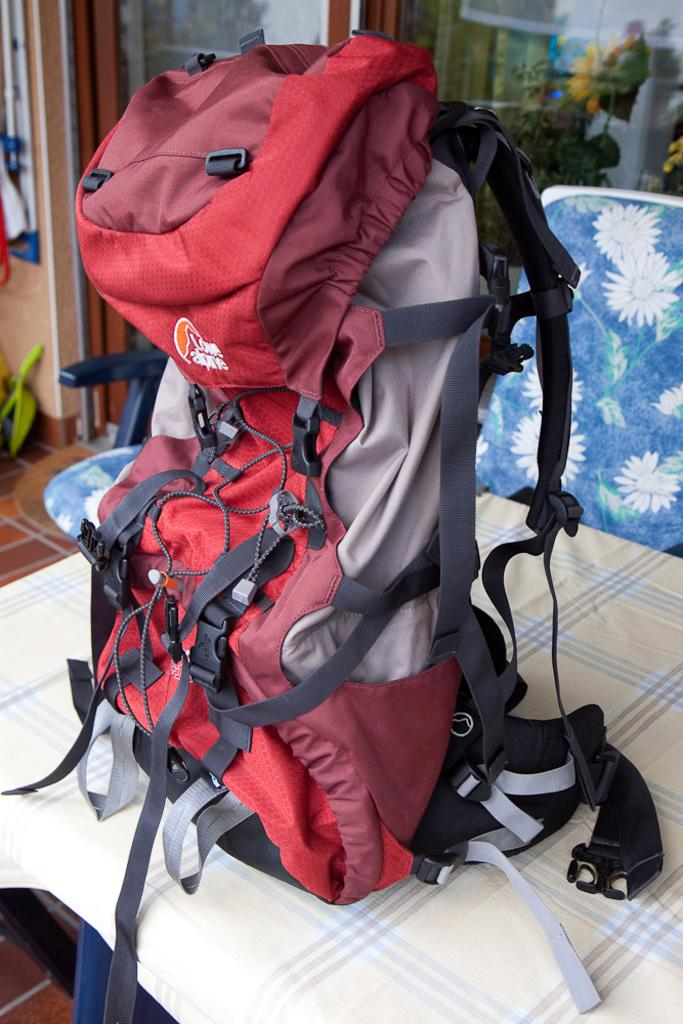What is placed on the table in the image? There is a backpack on the table. What type of furniture is present in the image? There is a chair in the image. What is covering the table in the image? There is a cloth on the table. What part of the room can be seen in the image? The floor is visible in the image. What direction is the test being taken in the image? There is no test present in the image, so it is not possible to determine the direction in which it would be taken. 